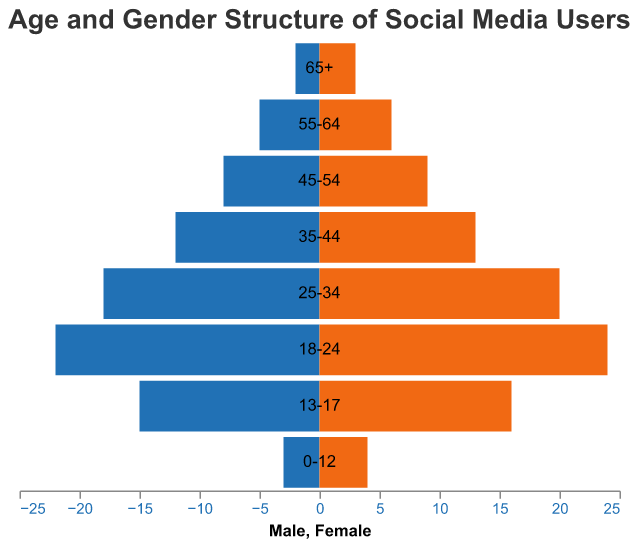What's the title of the figure? The title is at the top of the figure, displaying the main topic being visualized.
Answer: Age and Gender Structure of Social Media Users What age group has the highest number of female social media users? By checking the height of the bars associated with female users, the tallest bar corresponds to the "18-24" age group with 24 female users.
Answer: 18-24 Which gender has more users in the "35-44" age group? Compare the length of the bars for males and females in the "35-44" age group. The female bar (13) is slightly longer than the male bar (12).
Answer: Female How do the numbers of male and female users compare in the "25-34" age group? Look at the lengths of the bars for both genders in the "25-34" age group. The female bar shows 20 users and the male bar shows 18 users.
Answer: Females have 2 more users What is the total number of social media users in the "55-64" age group? Sum the number of male and female users: 5 males + 6 females = 11 users.
Answer: 11 What's the difference in the number of male users between the "18-24" and "13-17" age groups? Subtract the number of males in the "13-17" age group from those in the "18-24" group: 22 (18-24) - 15 (13-17) = 7
Answer: 7 Which age group has the least number of male and female users combined? Compare the combined user numbers for each age group. The "65+" group has 2 males + 3 females = 5 users, the least number.
Answer: 65+ Do males or females dominate the "45-54" age group in terms of social media usage? Compare the male and female bar lengths in the "45-54" group. Both are very close, with 8 males and 9 females, so females slightly dominate.
Answer: Females How many more users are in the "18-24" age group compared to the "13-17" age group? Add the number of users for each gender in both age groups. The "18-24" age group has 22 males + 24 females = 46 users. The "13-17" group has 15 males + 16 females = 31 users. The difference is 46 - 31 = 15 users.
Answer: 15 